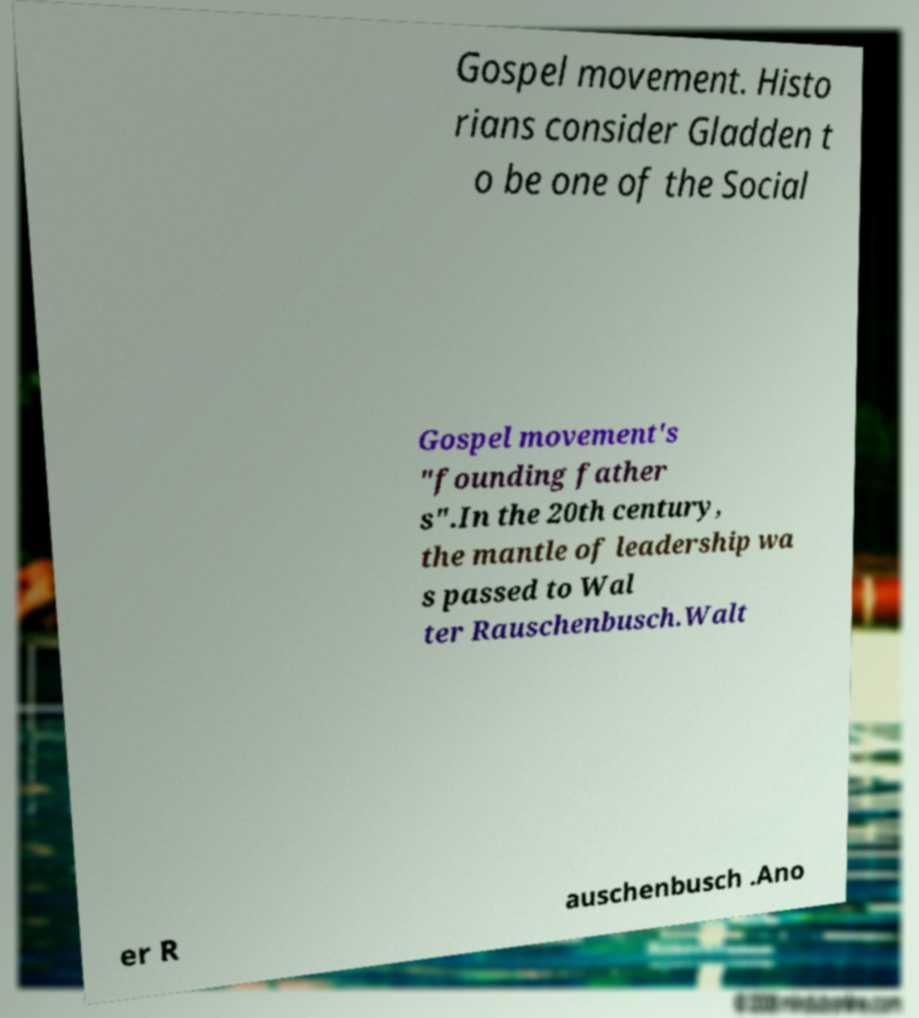For documentation purposes, I need the text within this image transcribed. Could you provide that? Gospel movement. Histo rians consider Gladden t o be one of the Social Gospel movement's "founding father s".In the 20th century, the mantle of leadership wa s passed to Wal ter Rauschenbusch.Walt er R auschenbusch .Ano 